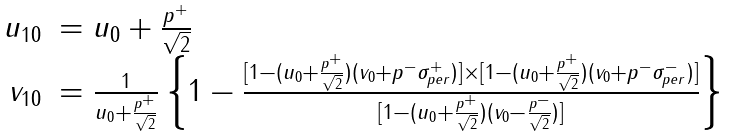<formula> <loc_0><loc_0><loc_500><loc_500>\begin{array} { r l } { { u _ { 1 0 } } } & { { = u _ { 0 } + \frac { p ^ { + } } { \sqrt { 2 } } } } \\ { { v _ { 1 0 } } } & { { = \frac { 1 } { u _ { 0 } + \frac { p ^ { + } } { \sqrt { 2 } } } \left \{ 1 - \frac { [ 1 - ( u _ { 0 } + \frac { p ^ { + } } { \sqrt { 2 } } ) ( v _ { 0 } + p ^ { - } \sigma _ { p e r } ^ { + } ) ] \times [ 1 - ( u _ { 0 } + \frac { p ^ { + } } { \sqrt { 2 } } ) ( v _ { 0 } + p ^ { - } \sigma _ { p e r } ^ { - } ) ] } { [ 1 - ( u _ { 0 } + \frac { p ^ { + } } { \sqrt { 2 } } ) ( v _ { 0 } - \frac { p ^ { - } } { \sqrt { 2 } } ) ] } \right \} } } \end{array}</formula> 